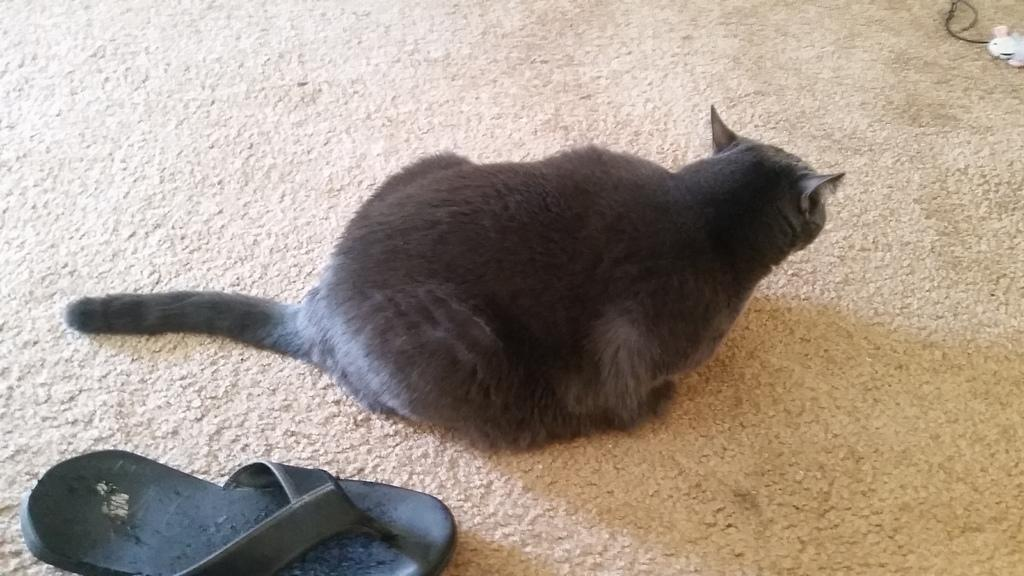What type of animal is in the image? There is a black cat in the image. Where is the cat located in relation to other objects in the image? The cat is sitting near a black slipper. What can be seen in the top right corner of the image? There is a trade mark or logo and a plastic object in the top right corner of the image. What type of prose can be heard coming from the cat in the image? Cats do not produce prose, so there is no prose coming from the cat in the image. 